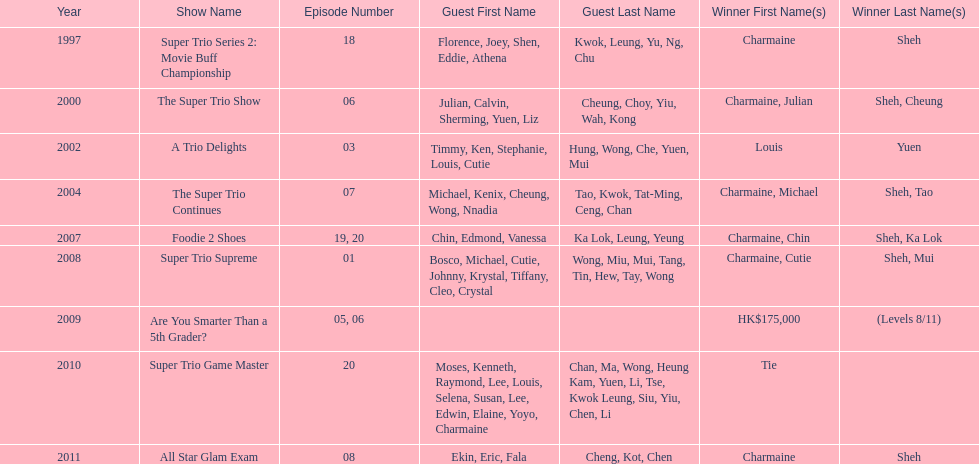What was the total number of trio series shows were charmaine sheh on? 6. 